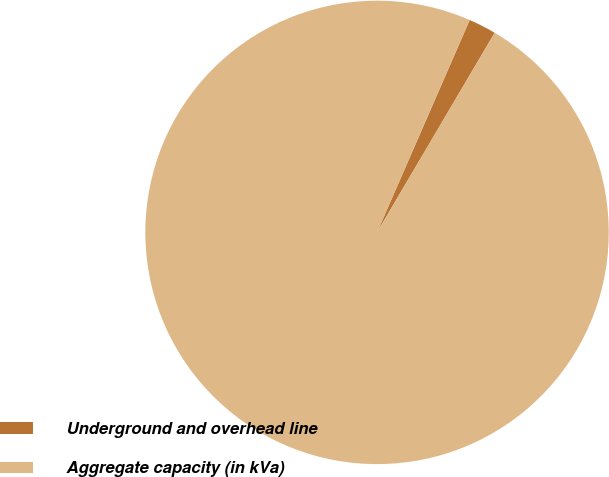Convert chart. <chart><loc_0><loc_0><loc_500><loc_500><pie_chart><fcel>Underground and overhead line<fcel>Aggregate capacity (in kVa)<nl><fcel>1.93%<fcel>98.07%<nl></chart> 